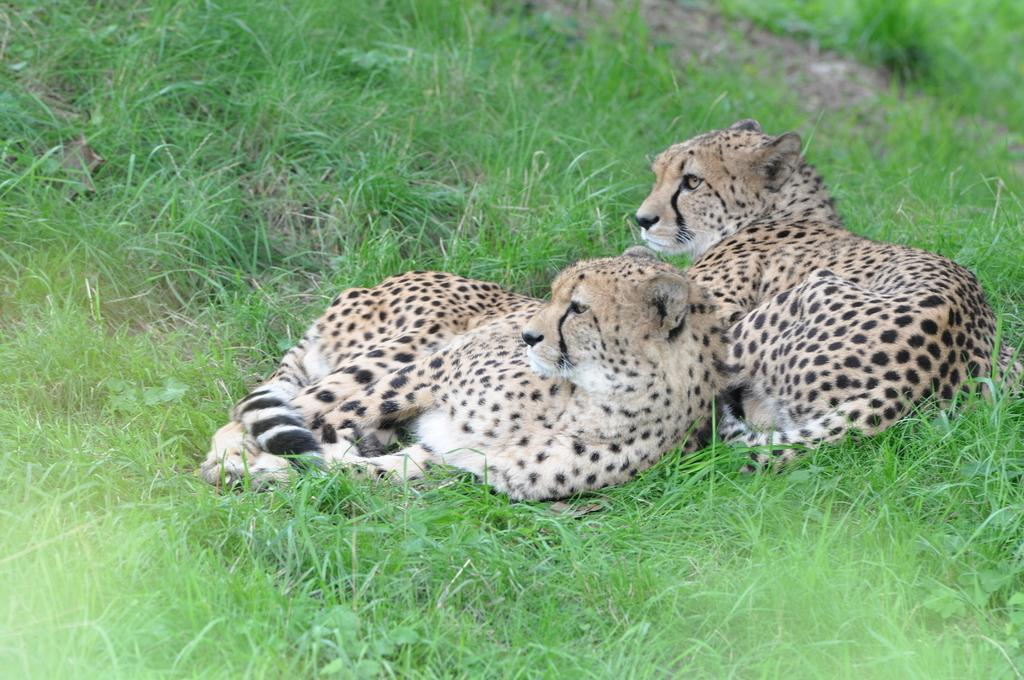What type of surface is visible on the ground in the image? There is grass on the ground in the image. What are the animals doing in the image? The animals are sitting on the ground in the image. What type of cattle can be seen grazing on the grass in the image? There is no cattle present in the image; it only shows animals sitting on the grass. How do the animals move around in the image? The animals are sitting in the image, so they are not moving around. 